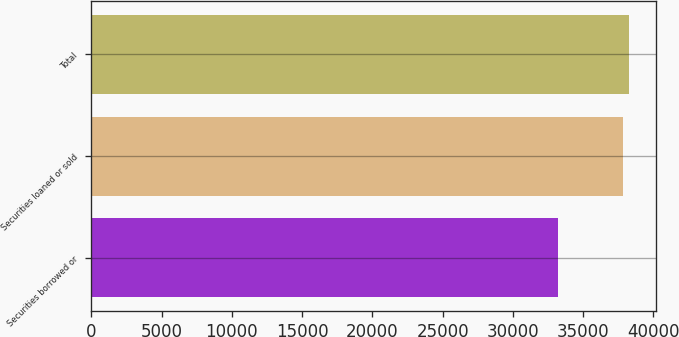Convert chart to OTSL. <chart><loc_0><loc_0><loc_500><loc_500><bar_chart><fcel>Securities borrowed or<fcel>Securities loaned or sold<fcel>Total<nl><fcel>33196<fcel>37809<fcel>38270.3<nl></chart> 